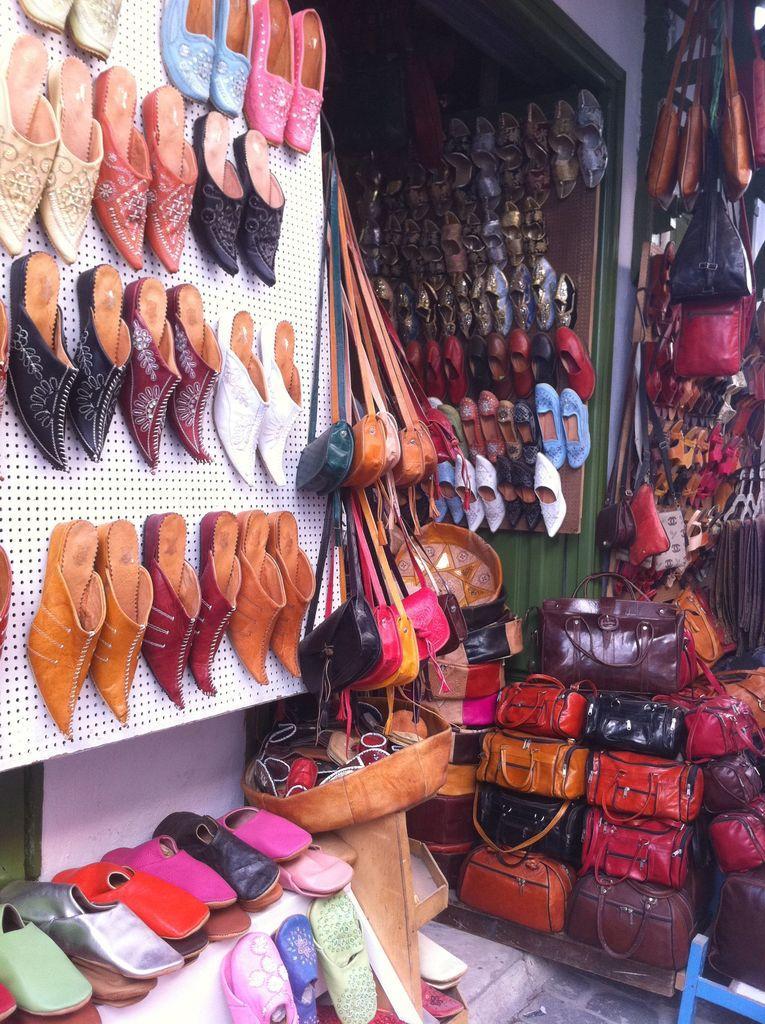In one or two sentences, can you explain what this image depicts? In this image, we can see a shop contains bags and some footwear. 